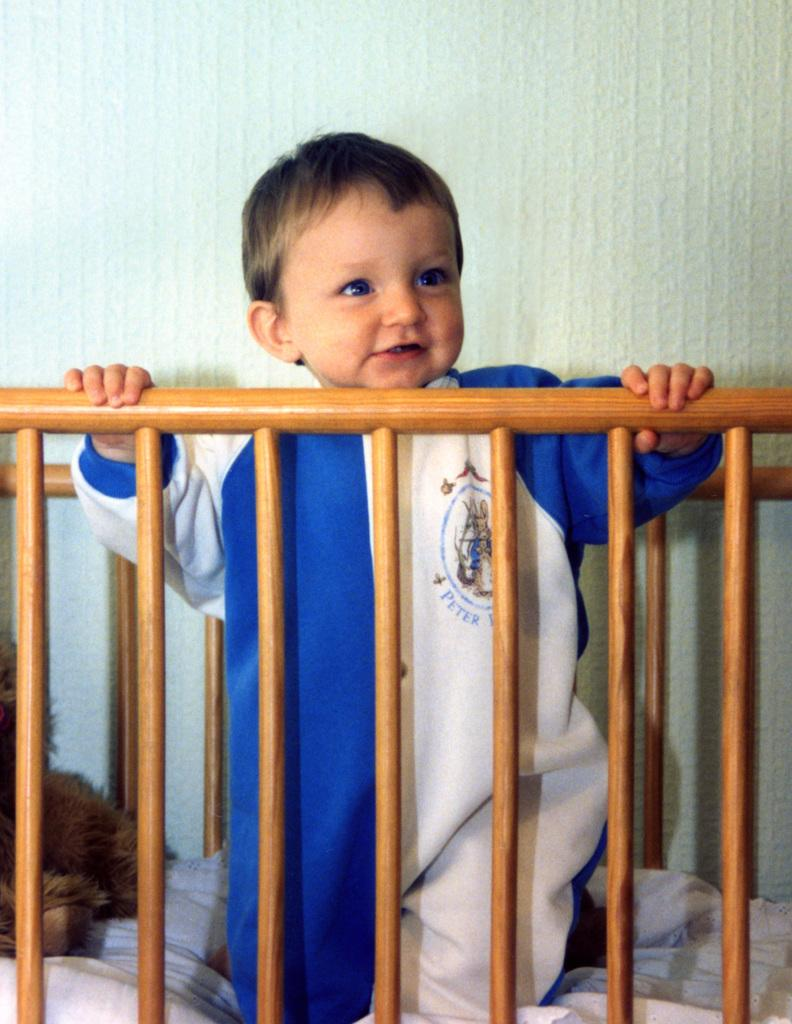Who is present in the image? There is a boy in the image. What is on the bed with the boy? There is a toy on the bed. Where are the boy and the toy located? The boy and the toy are on a bed. What can be seen in the background of the image? There is a wall in the background of the image. How many cards are on the shelf in the image? There is no shelf or cards present in the image. 